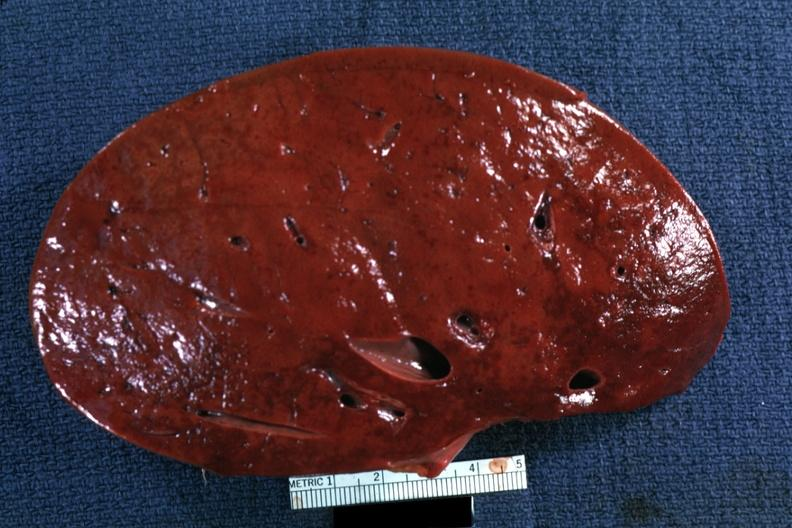s malignant thymoma had?
Answer the question using a single word or phrase. No 